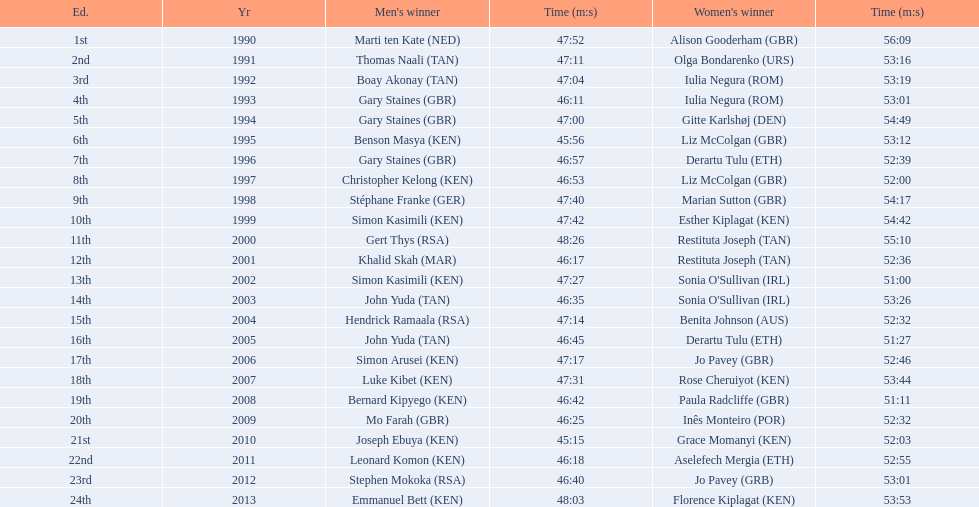What are the names of each male winner? Marti ten Kate (NED), Thomas Naali (TAN), Boay Akonay (TAN), Gary Staines (GBR), Gary Staines (GBR), Benson Masya (KEN), Gary Staines (GBR), Christopher Kelong (KEN), Stéphane Franke (GER), Simon Kasimili (KEN), Gert Thys (RSA), Khalid Skah (MAR), Simon Kasimili (KEN), John Yuda (TAN), Hendrick Ramaala (RSA), John Yuda (TAN), Simon Arusei (KEN), Luke Kibet (KEN), Bernard Kipyego (KEN), Mo Farah (GBR), Joseph Ebuya (KEN), Leonard Komon (KEN), Stephen Mokoka (RSA), Emmanuel Bett (KEN). When did they race? 1990, 1991, 1992, 1993, 1994, 1995, 1996, 1997, 1998, 1999, 2000, 2001, 2002, 2003, 2004, 2005, 2006, 2007, 2008, 2009, 2010, 2011, 2012, 2013. And what were their times? 47:52, 47:11, 47:04, 46:11, 47:00, 45:56, 46:57, 46:53, 47:40, 47:42, 48:26, 46:17, 47:27, 46:35, 47:14, 46:45, 47:17, 47:31, 46:42, 46:25, 45:15, 46:18, 46:40, 48:03. Of those times, which athlete had the fastest time? Joseph Ebuya (KEN). 